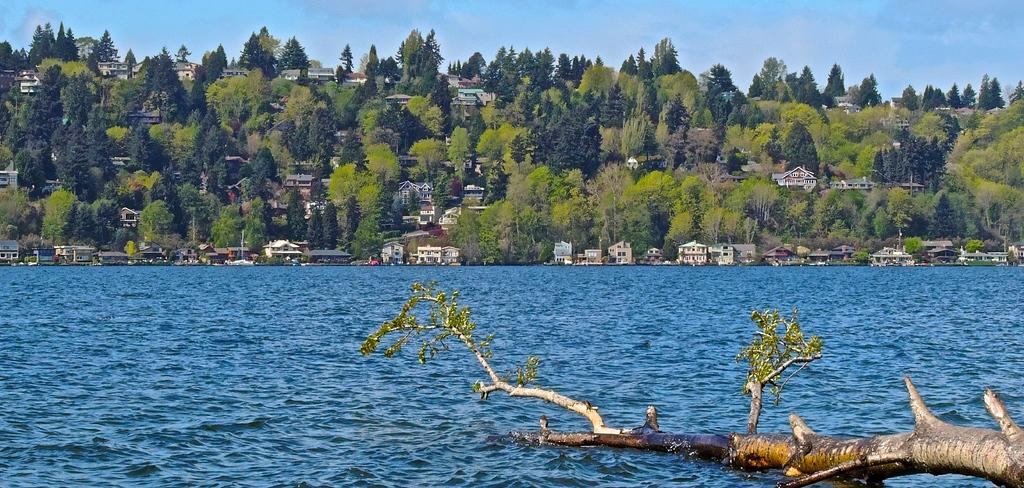What is located in the water in the image? There is a branch in the water in the image. What can be seen in the distance in the image? There are houses and trees visible in the background of the image. What is visible above the houses and trees in the image? The sky is visible in the background of the image. Can you see any cherries on the branch in the image? There are no cherries visible on the branch in the image. Who made the request for the branch to be placed in the water? The image does not provide any information about who made the request or why the branch is in the water. 